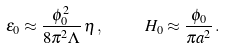<formula> <loc_0><loc_0><loc_500><loc_500>\epsilon _ { 0 } \approx \frac { \phi _ { 0 } ^ { 2 } } { 8 \pi ^ { 2 } \Lambda } \, \eta \, , \quad \ H _ { 0 } \approx \frac { \phi _ { 0 } } { \pi a ^ { 2 } } \, .</formula> 